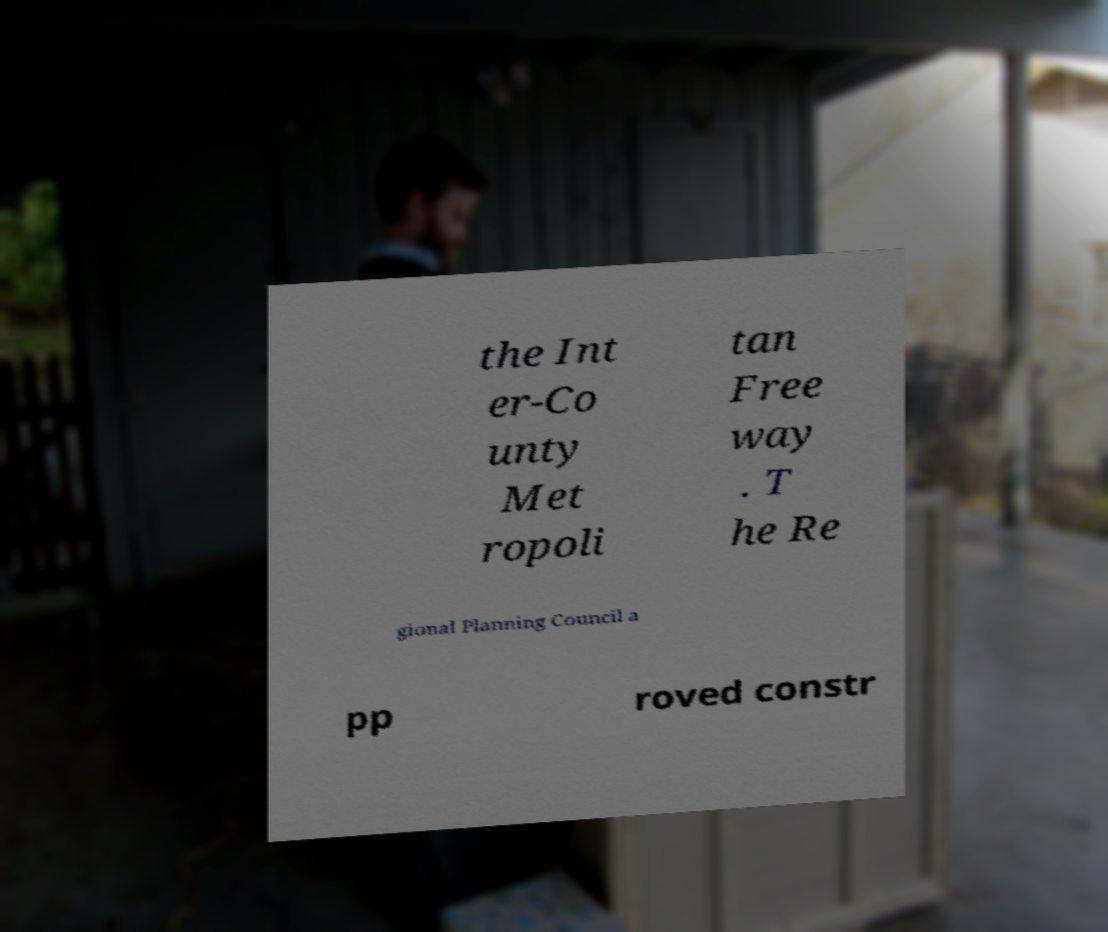Please read and relay the text visible in this image. What does it say? the Int er-Co unty Met ropoli tan Free way . T he Re gional Planning Council a pp roved constr 